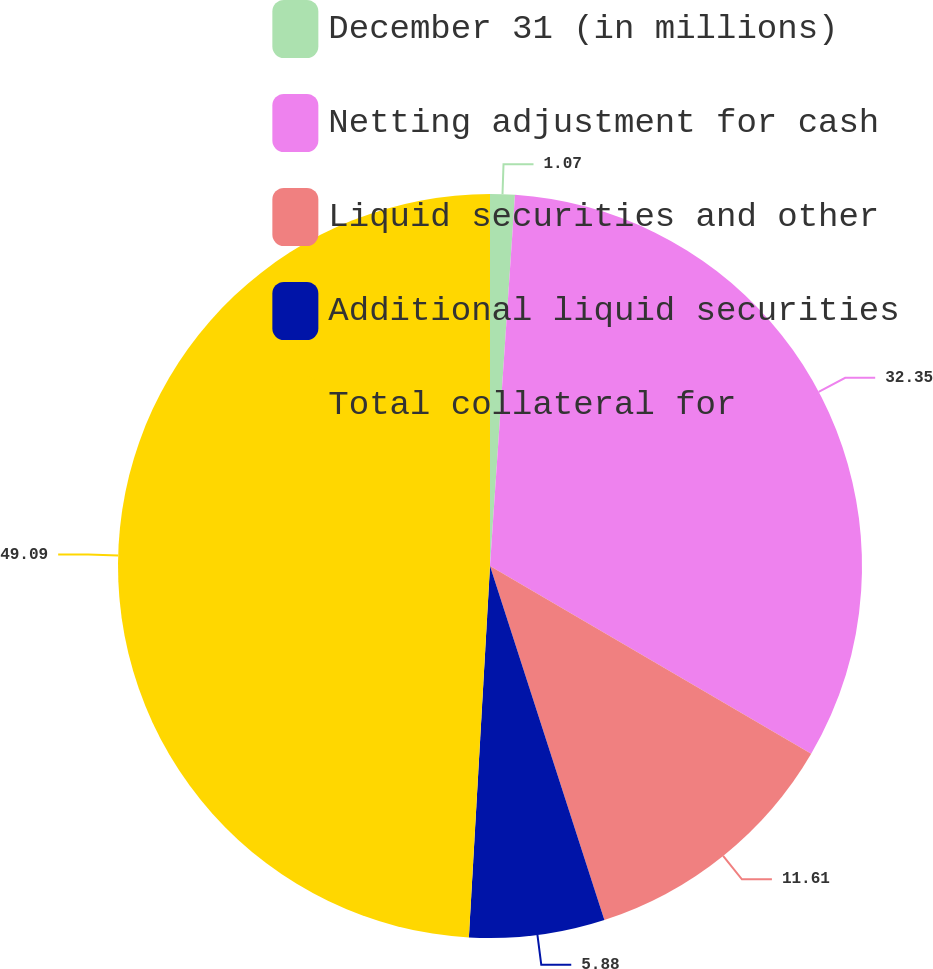Convert chart to OTSL. <chart><loc_0><loc_0><loc_500><loc_500><pie_chart><fcel>December 31 (in millions)<fcel>Netting adjustment for cash<fcel>Liquid securities and other<fcel>Additional liquid securities<fcel>Total collateral for<nl><fcel>1.07%<fcel>32.35%<fcel>11.61%<fcel>5.88%<fcel>49.1%<nl></chart> 